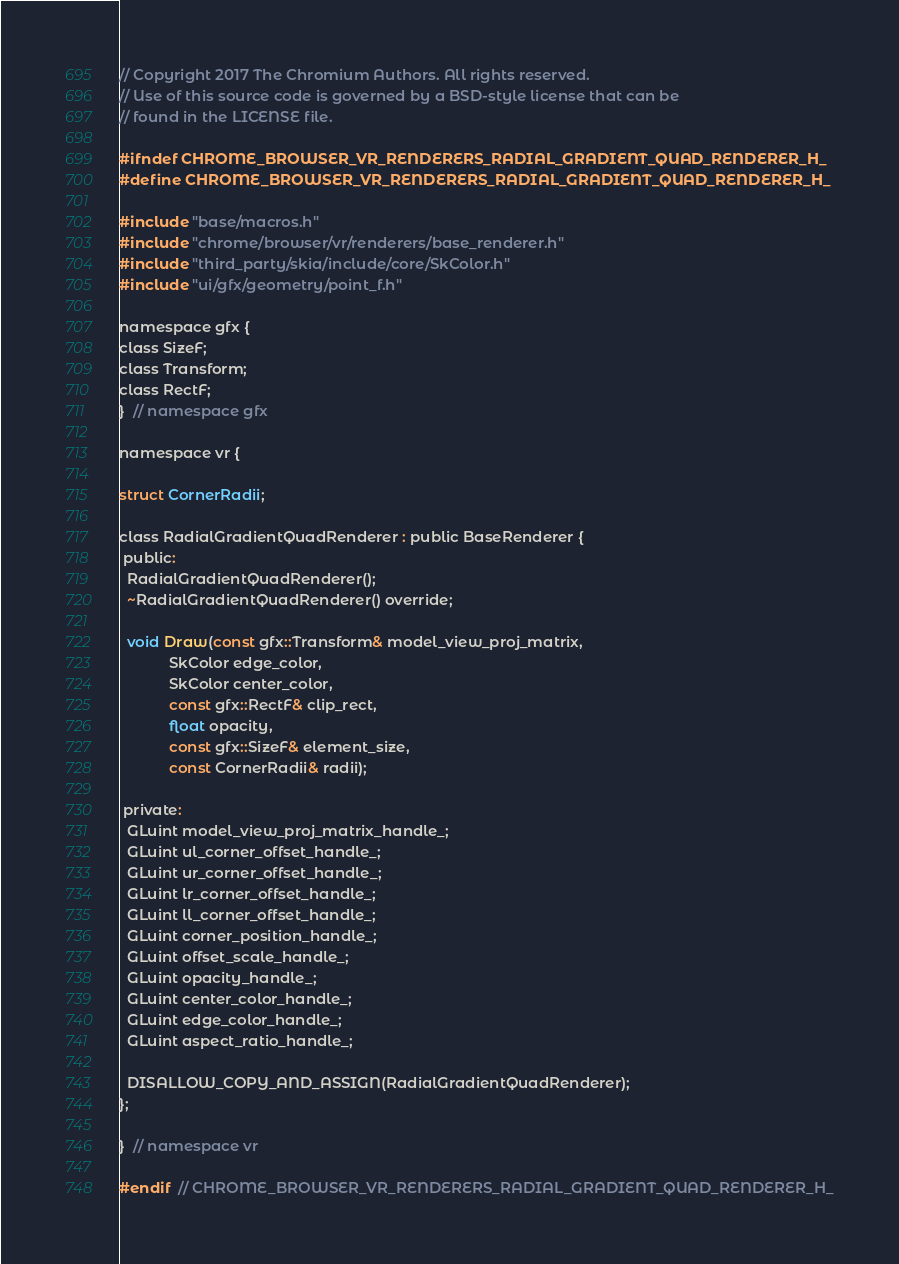Convert code to text. <code><loc_0><loc_0><loc_500><loc_500><_C_>// Copyright 2017 The Chromium Authors. All rights reserved.
// Use of this source code is governed by a BSD-style license that can be
// found in the LICENSE file.

#ifndef CHROME_BROWSER_VR_RENDERERS_RADIAL_GRADIENT_QUAD_RENDERER_H_
#define CHROME_BROWSER_VR_RENDERERS_RADIAL_GRADIENT_QUAD_RENDERER_H_

#include "base/macros.h"
#include "chrome/browser/vr/renderers/base_renderer.h"
#include "third_party/skia/include/core/SkColor.h"
#include "ui/gfx/geometry/point_f.h"

namespace gfx {
class SizeF;
class Transform;
class RectF;
}  // namespace gfx

namespace vr {

struct CornerRadii;

class RadialGradientQuadRenderer : public BaseRenderer {
 public:
  RadialGradientQuadRenderer();
  ~RadialGradientQuadRenderer() override;

  void Draw(const gfx::Transform& model_view_proj_matrix,
            SkColor edge_color,
            SkColor center_color,
            const gfx::RectF& clip_rect,
            float opacity,
            const gfx::SizeF& element_size,
            const CornerRadii& radii);

 private:
  GLuint model_view_proj_matrix_handle_;
  GLuint ul_corner_offset_handle_;
  GLuint ur_corner_offset_handle_;
  GLuint lr_corner_offset_handle_;
  GLuint ll_corner_offset_handle_;
  GLuint corner_position_handle_;
  GLuint offset_scale_handle_;
  GLuint opacity_handle_;
  GLuint center_color_handle_;
  GLuint edge_color_handle_;
  GLuint aspect_ratio_handle_;

  DISALLOW_COPY_AND_ASSIGN(RadialGradientQuadRenderer);
};

}  // namespace vr

#endif  // CHROME_BROWSER_VR_RENDERERS_RADIAL_GRADIENT_QUAD_RENDERER_H_
</code> 